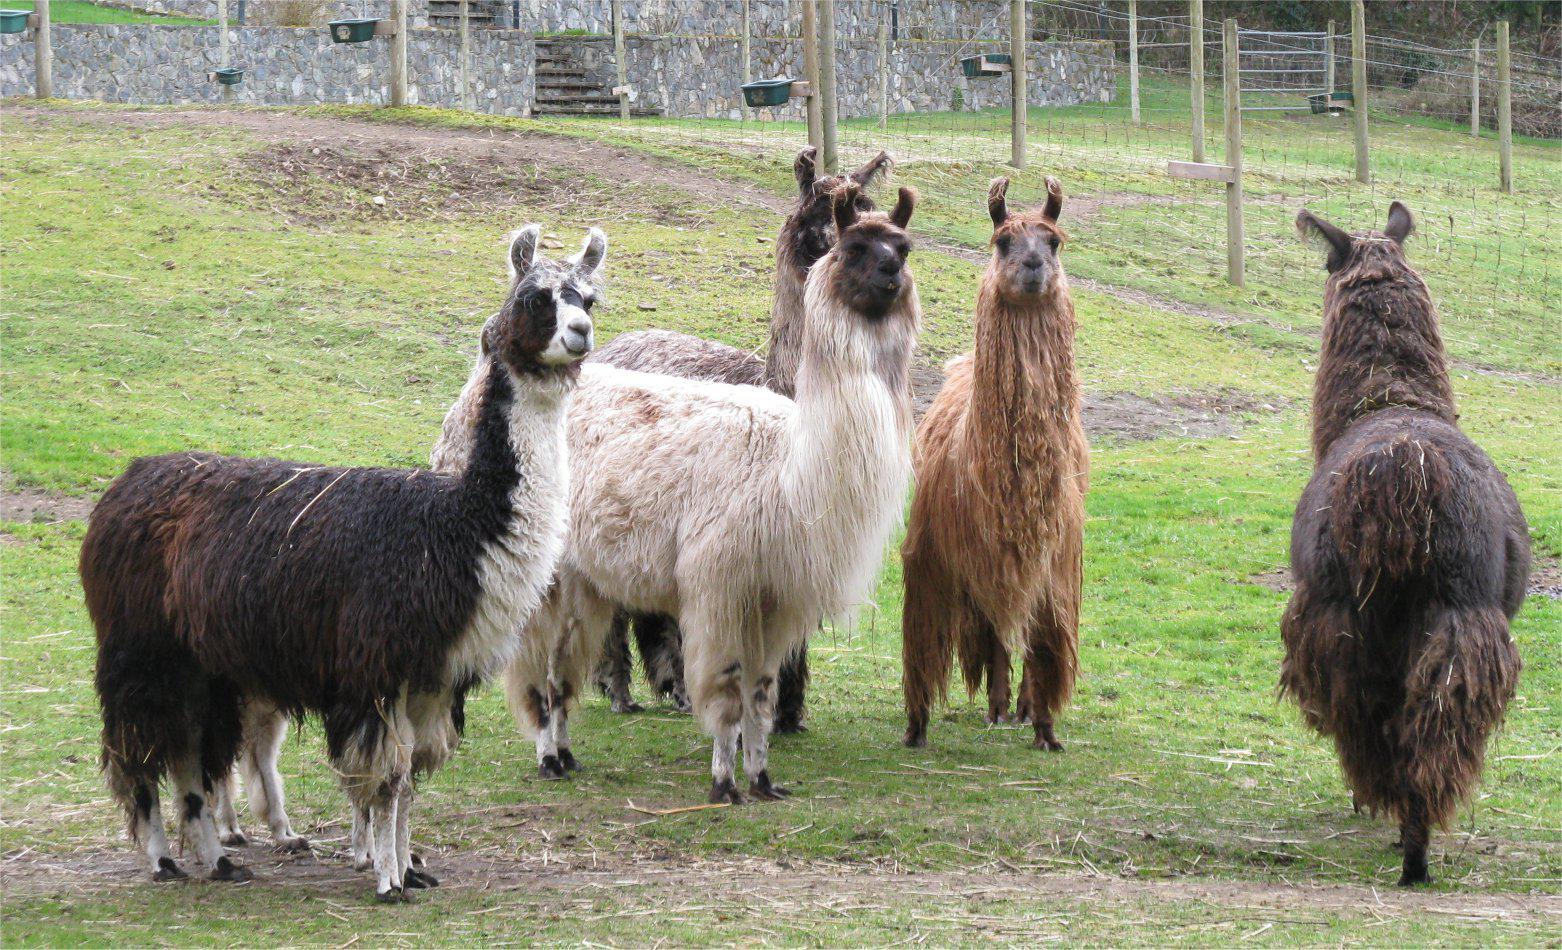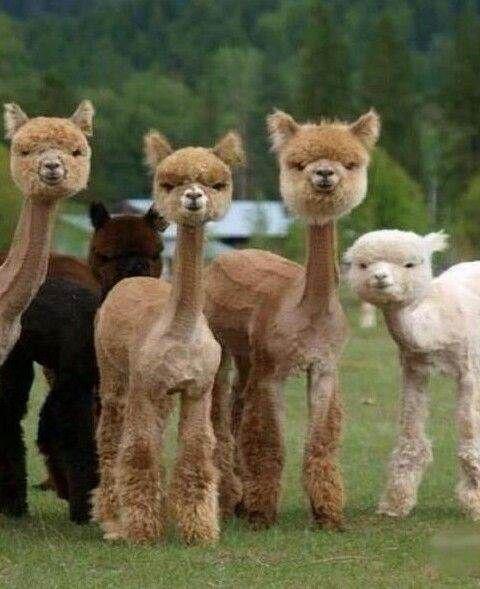The first image is the image on the left, the second image is the image on the right. Analyze the images presented: Is the assertion "At least one photo shows an animal with brightly colored tassels near its ears." valid? Answer yes or no. No. The first image is the image on the left, the second image is the image on the right. For the images shown, is this caption "One of the images shows a llama with multicolored yarn decorations hanging from its ears." true? Answer yes or no. No. 